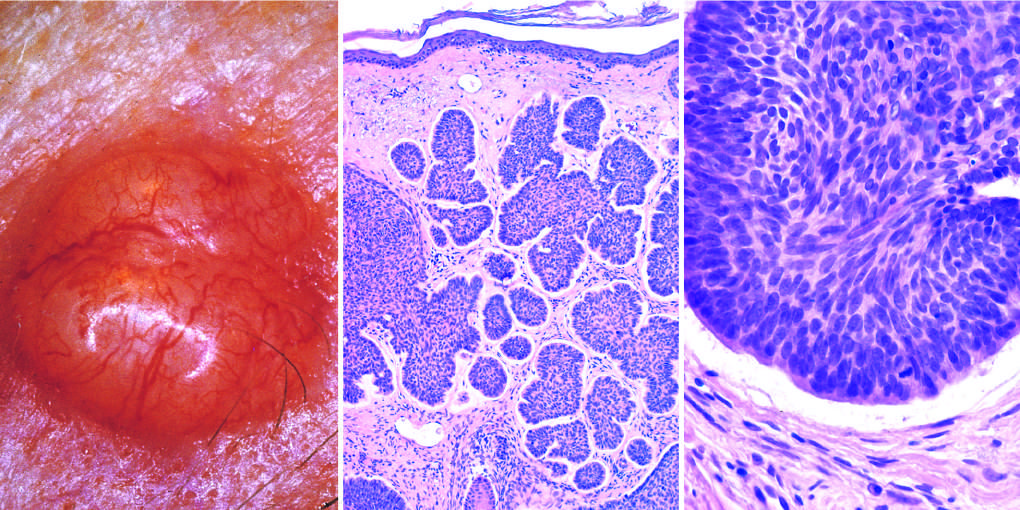what is composed of nests of basaloid cells infiltrating a fibrotic stroma?
Answer the question using a single word or phrase. The tumor 